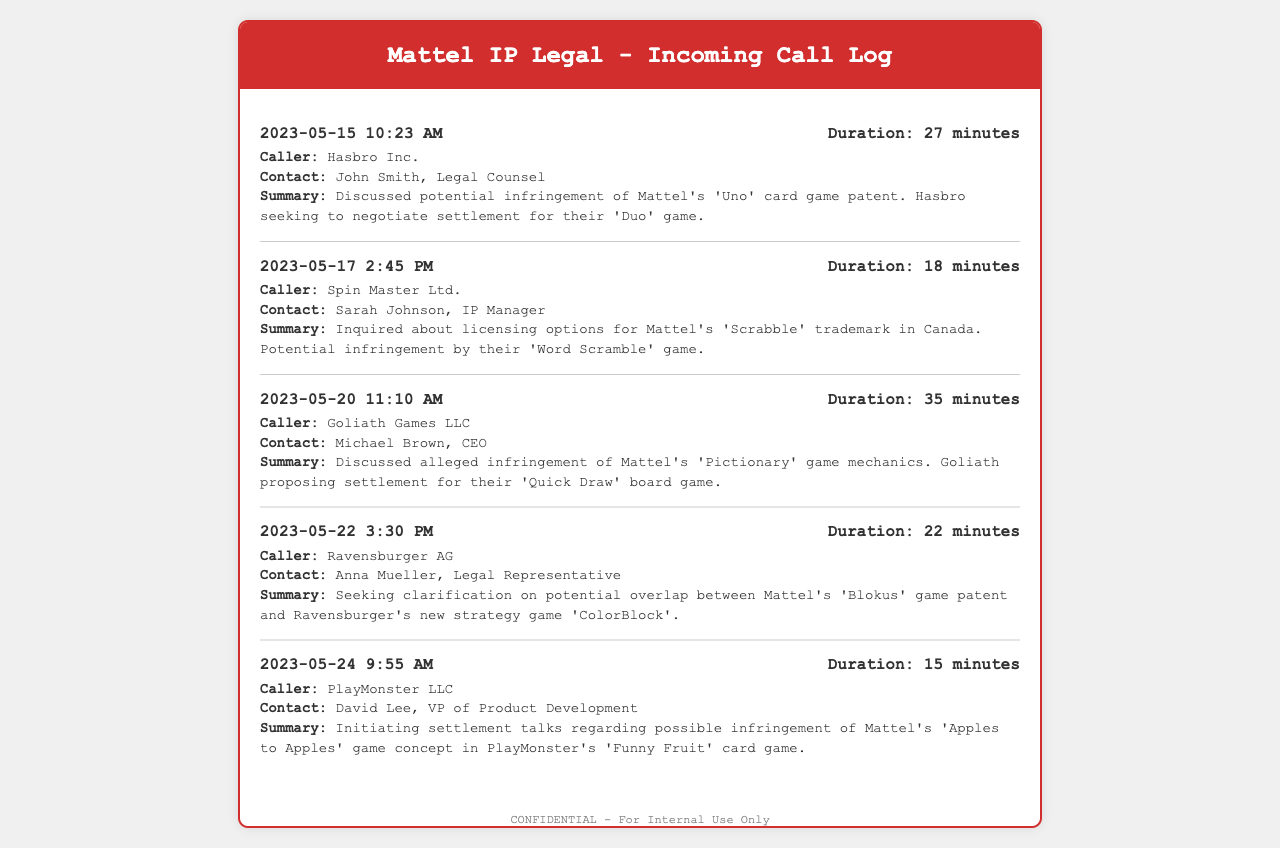What is the date of the call from Hasbro Inc.? The date of the call from Hasbro Inc. is mentioned in the call entry, which is 2023-05-15.
Answer: 2023-05-15 What is the duration of the call with Spin Master Ltd.? The duration of the call with Spin Master Ltd. is stated directly in the call entry as 18 minutes.
Answer: 18 minutes Who is the contact person for Goliath Games LLC? The contact person for Goliath Games LLC is identified in the call entry as Michael Brown, CEO.
Answer: Michael Brown, CEO What game is Ravensburger AG inquiring about? Ravensburger AG is inquiring about potential overlap with Mattel's 'Blokus' game patent as detailed in the call summary.
Answer: 'Blokus' How many minutes was the call with PlayMonster LLC? The call with PlayMonster LLC lasted 15 minutes, which is specified in the call log details.
Answer: 15 minutes Which company proposed a settlement regarding 'Quick Draw'? The company proposing a settlement regarding 'Quick Draw' is mentioned as Goliath Games LLC in the call summary.
Answer: Goliath Games LLC What is the reason for Spin Master Ltd.'s call? Spin Master Ltd. called about licensing options for Mattel's 'Scrabble' trademark due to potential infringement by their 'Word Scramble' game.
Answer: Licensing options for 'Scrabble' How many calls were made regarding Mattel's 'Pictionary'? There was one call made regarding Mattel's 'Pictionary', indicated by the call with Goliath Games LLC.
Answer: One call 